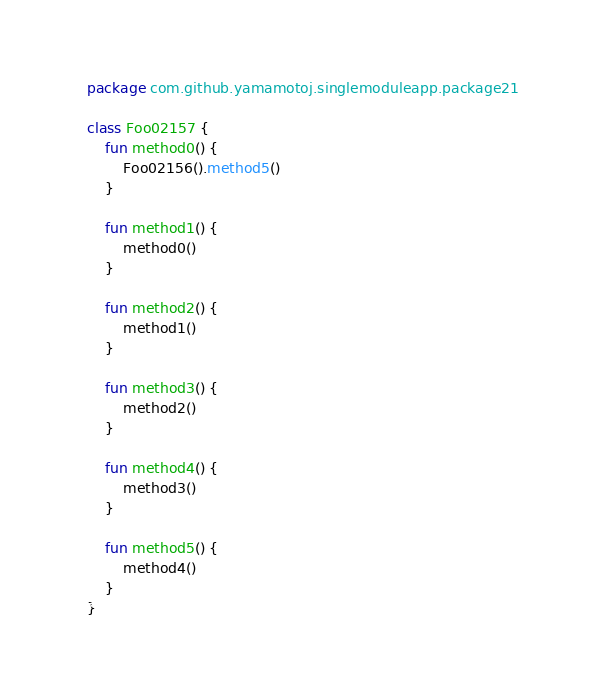<code> <loc_0><loc_0><loc_500><loc_500><_Kotlin_>package com.github.yamamotoj.singlemoduleapp.package21

class Foo02157 {
    fun method0() {
        Foo02156().method5()
    }

    fun method1() {
        method0()
    }

    fun method2() {
        method1()
    }

    fun method3() {
        method2()
    }

    fun method4() {
        method3()
    }

    fun method5() {
        method4()
    }
}
</code> 